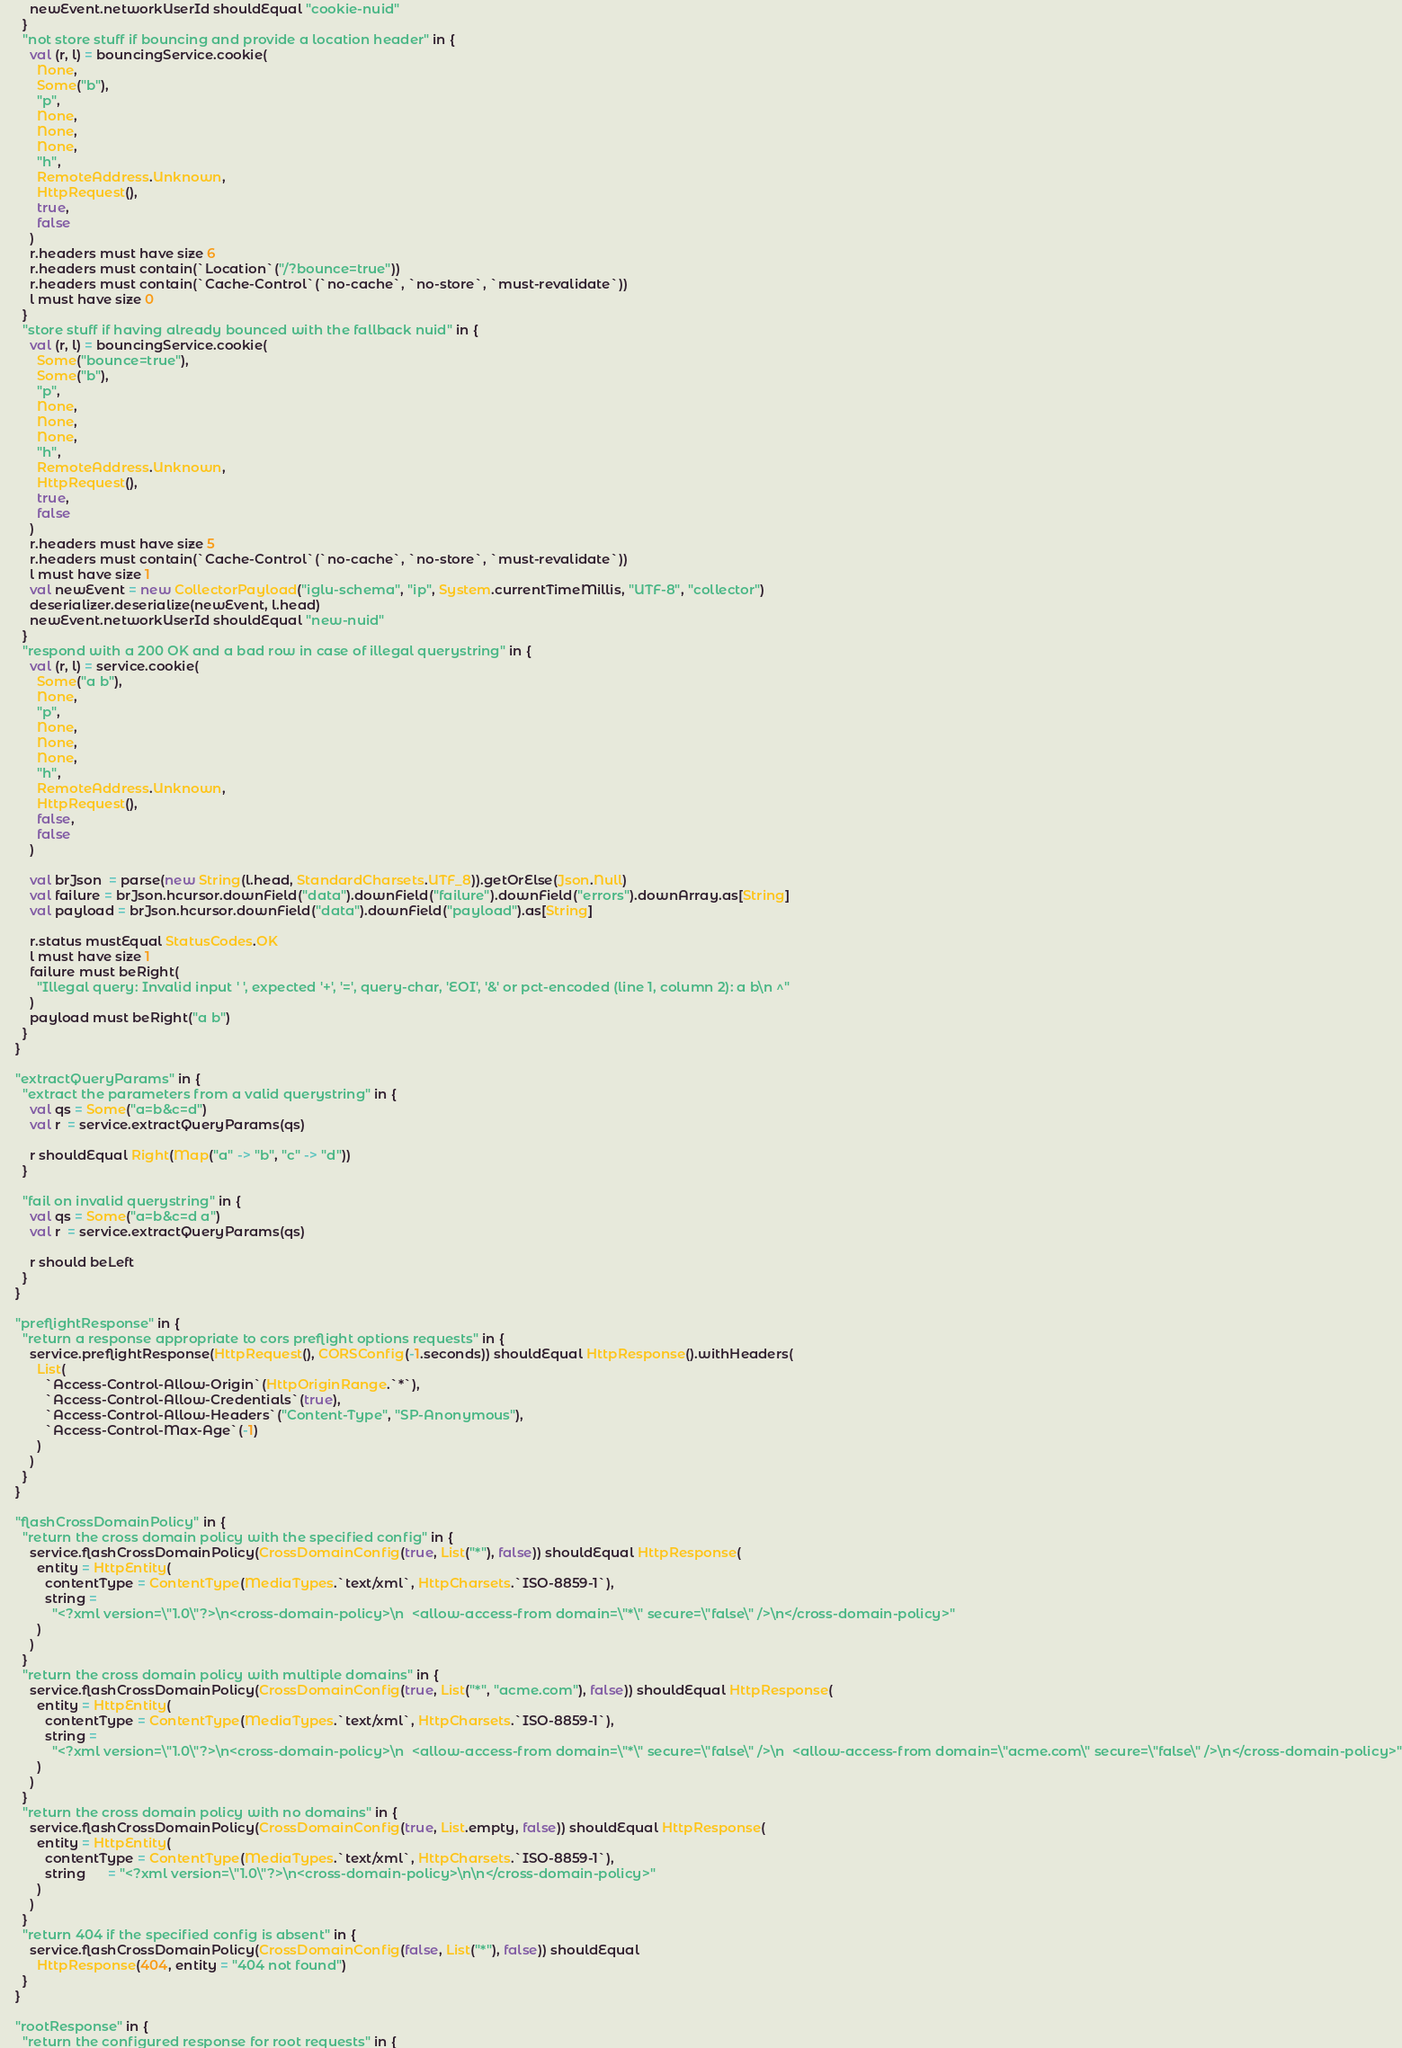Convert code to text. <code><loc_0><loc_0><loc_500><loc_500><_Scala_>        newEvent.networkUserId shouldEqual "cookie-nuid"
      }
      "not store stuff if bouncing and provide a location header" in {
        val (r, l) = bouncingService.cookie(
          None,
          Some("b"),
          "p",
          None,
          None,
          None,
          "h",
          RemoteAddress.Unknown,
          HttpRequest(),
          true,
          false
        )
        r.headers must have size 6
        r.headers must contain(`Location`("/?bounce=true"))
        r.headers must contain(`Cache-Control`(`no-cache`, `no-store`, `must-revalidate`))
        l must have size 0
      }
      "store stuff if having already bounced with the fallback nuid" in {
        val (r, l) = bouncingService.cookie(
          Some("bounce=true"),
          Some("b"),
          "p",
          None,
          None,
          None,
          "h",
          RemoteAddress.Unknown,
          HttpRequest(),
          true,
          false
        )
        r.headers must have size 5
        r.headers must contain(`Cache-Control`(`no-cache`, `no-store`, `must-revalidate`))
        l must have size 1
        val newEvent = new CollectorPayload("iglu-schema", "ip", System.currentTimeMillis, "UTF-8", "collector")
        deserializer.deserialize(newEvent, l.head)
        newEvent.networkUserId shouldEqual "new-nuid"
      }
      "respond with a 200 OK and a bad row in case of illegal querystring" in {
        val (r, l) = service.cookie(
          Some("a b"),
          None,
          "p",
          None,
          None,
          None,
          "h",
          RemoteAddress.Unknown,
          HttpRequest(),
          false,
          false
        )

        val brJson  = parse(new String(l.head, StandardCharsets.UTF_8)).getOrElse(Json.Null)
        val failure = brJson.hcursor.downField("data").downField("failure").downField("errors").downArray.as[String]
        val payload = brJson.hcursor.downField("data").downField("payload").as[String]

        r.status mustEqual StatusCodes.OK
        l must have size 1
        failure must beRight(
          "Illegal query: Invalid input ' ', expected '+', '=', query-char, 'EOI', '&' or pct-encoded (line 1, column 2): a b\n ^"
        )
        payload must beRight("a b")
      }
    }

    "extractQueryParams" in {
      "extract the parameters from a valid querystring" in {
        val qs = Some("a=b&c=d")
        val r  = service.extractQueryParams(qs)

        r shouldEqual Right(Map("a" -> "b", "c" -> "d"))
      }

      "fail on invalid querystring" in {
        val qs = Some("a=b&c=d a")
        val r  = service.extractQueryParams(qs)

        r should beLeft
      }
    }

    "preflightResponse" in {
      "return a response appropriate to cors preflight options requests" in {
        service.preflightResponse(HttpRequest(), CORSConfig(-1.seconds)) shouldEqual HttpResponse().withHeaders(
          List(
            `Access-Control-Allow-Origin`(HttpOriginRange.`*`),
            `Access-Control-Allow-Credentials`(true),
            `Access-Control-Allow-Headers`("Content-Type", "SP-Anonymous"),
            `Access-Control-Max-Age`(-1)
          )
        )
      }
    }

    "flashCrossDomainPolicy" in {
      "return the cross domain policy with the specified config" in {
        service.flashCrossDomainPolicy(CrossDomainConfig(true, List("*"), false)) shouldEqual HttpResponse(
          entity = HttpEntity(
            contentType = ContentType(MediaTypes.`text/xml`, HttpCharsets.`ISO-8859-1`),
            string =
              "<?xml version=\"1.0\"?>\n<cross-domain-policy>\n  <allow-access-from domain=\"*\" secure=\"false\" />\n</cross-domain-policy>"
          )
        )
      }
      "return the cross domain policy with multiple domains" in {
        service.flashCrossDomainPolicy(CrossDomainConfig(true, List("*", "acme.com"), false)) shouldEqual HttpResponse(
          entity = HttpEntity(
            contentType = ContentType(MediaTypes.`text/xml`, HttpCharsets.`ISO-8859-1`),
            string =
              "<?xml version=\"1.0\"?>\n<cross-domain-policy>\n  <allow-access-from domain=\"*\" secure=\"false\" />\n  <allow-access-from domain=\"acme.com\" secure=\"false\" />\n</cross-domain-policy>"
          )
        )
      }
      "return the cross domain policy with no domains" in {
        service.flashCrossDomainPolicy(CrossDomainConfig(true, List.empty, false)) shouldEqual HttpResponse(
          entity = HttpEntity(
            contentType = ContentType(MediaTypes.`text/xml`, HttpCharsets.`ISO-8859-1`),
            string      = "<?xml version=\"1.0\"?>\n<cross-domain-policy>\n\n</cross-domain-policy>"
          )
        )
      }
      "return 404 if the specified config is absent" in {
        service.flashCrossDomainPolicy(CrossDomainConfig(false, List("*"), false)) shouldEqual
          HttpResponse(404, entity = "404 not found")
      }
    }

    "rootResponse" in {
      "return the configured response for root requests" in {</code> 